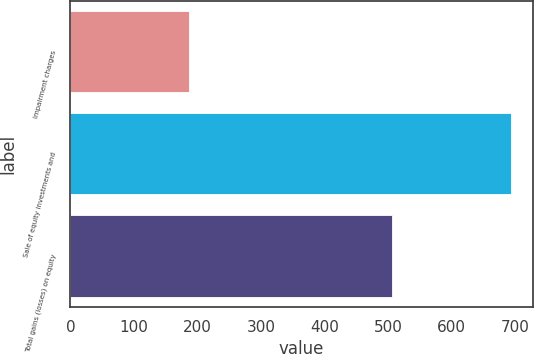Convert chart to OTSL. <chart><loc_0><loc_0><loc_500><loc_500><bar_chart><fcel>Impairment charges<fcel>Sale of equity investments and<fcel>Total gains (losses) on equity<nl><fcel>187<fcel>693<fcel>506<nl></chart> 